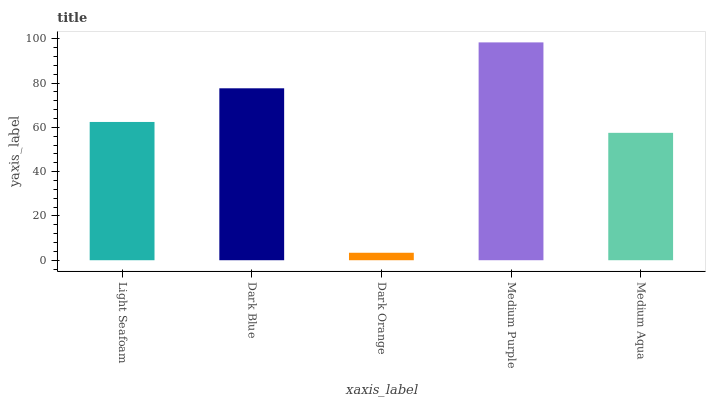Is Dark Blue the minimum?
Answer yes or no. No. Is Dark Blue the maximum?
Answer yes or no. No. Is Dark Blue greater than Light Seafoam?
Answer yes or no. Yes. Is Light Seafoam less than Dark Blue?
Answer yes or no. Yes. Is Light Seafoam greater than Dark Blue?
Answer yes or no. No. Is Dark Blue less than Light Seafoam?
Answer yes or no. No. Is Light Seafoam the high median?
Answer yes or no. Yes. Is Light Seafoam the low median?
Answer yes or no. Yes. Is Dark Orange the high median?
Answer yes or no. No. Is Dark Orange the low median?
Answer yes or no. No. 